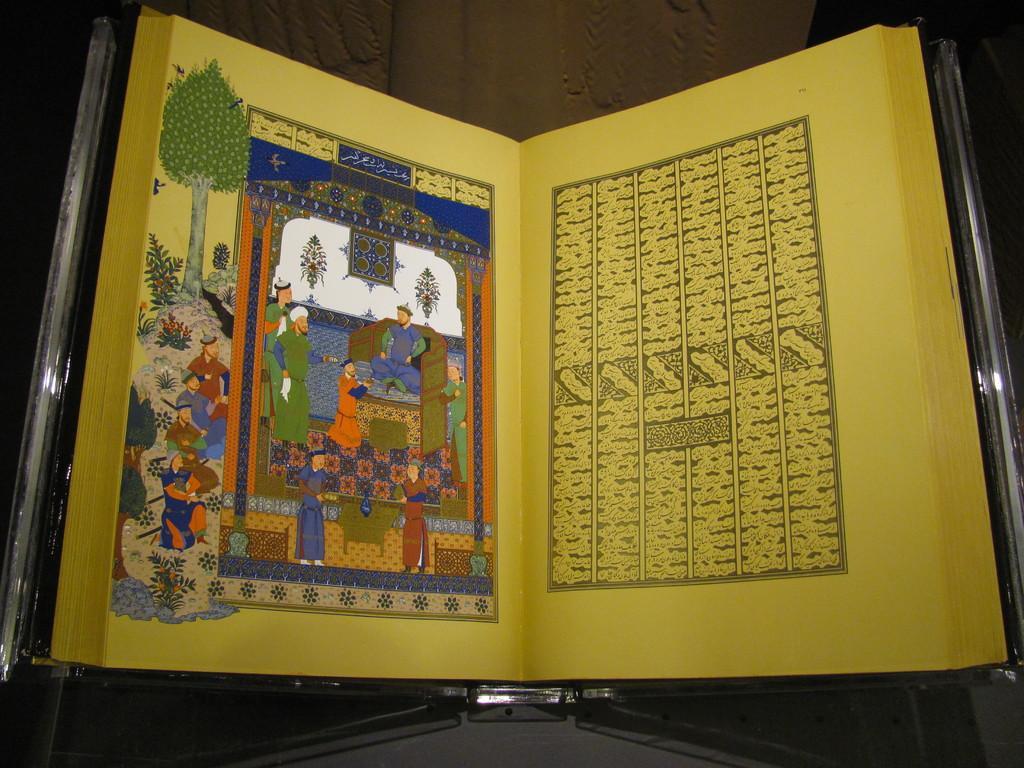How would you summarize this image in a sentence or two? In this image we can see a book with some text and drawings in it. 